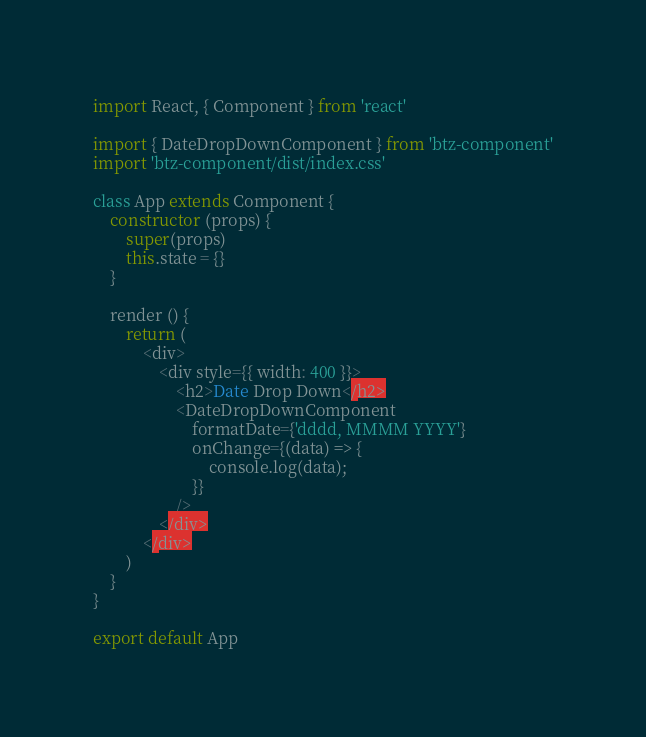Convert code to text. <code><loc_0><loc_0><loc_500><loc_500><_JavaScript_>import React, { Component } from 'react'

import { DateDropDownComponent } from 'btz-component'
import 'btz-component/dist/index.css'

class App extends Component {
    constructor (props) {
    	super(props)
    	this.state = {}
    }

    render () {
        return (
            <div>
                <div style={{ width: 400 }}>
                    <h2>Date Drop Down</h2>
                    <DateDropDownComponent 
                        formatDate={'dddd, MMMM YYYY'} 
                        onChange={(data) => {
                            console.log(data);
                        }} 
                    />
                </div>
            </div>
        )
    }
}

export default App
</code> 